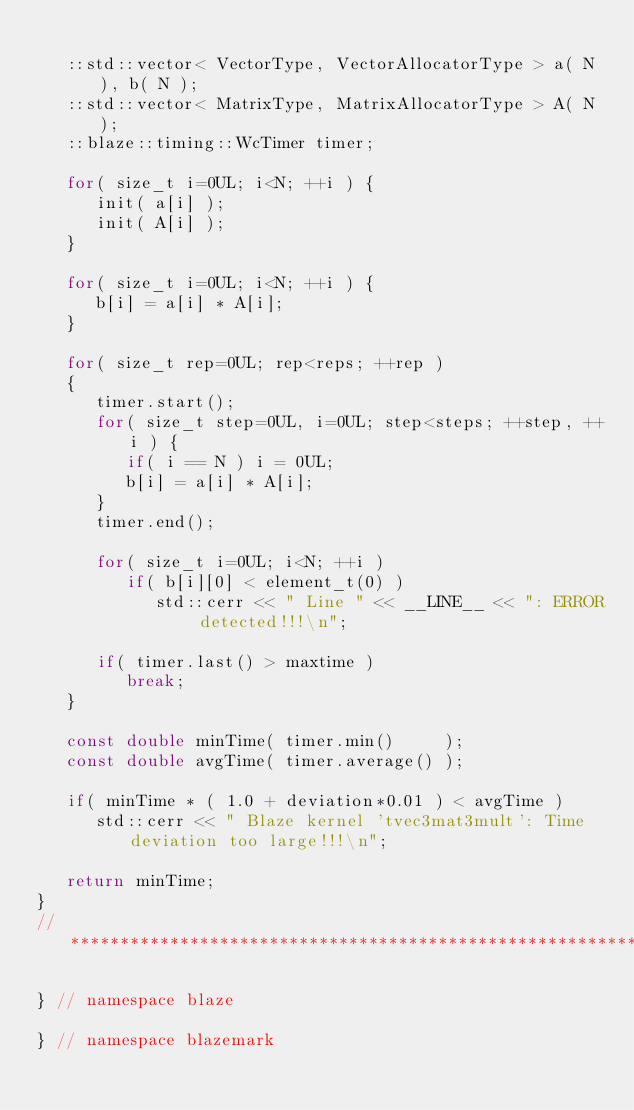Convert code to text. <code><loc_0><loc_0><loc_500><loc_500><_C++_>
   ::std::vector< VectorType, VectorAllocatorType > a( N ), b( N );
   ::std::vector< MatrixType, MatrixAllocatorType > A( N );
   ::blaze::timing::WcTimer timer;

   for( size_t i=0UL; i<N; ++i ) {
      init( a[i] );
      init( A[i] );
   }

   for( size_t i=0UL; i<N; ++i ) {
      b[i] = a[i] * A[i];
   }

   for( size_t rep=0UL; rep<reps; ++rep )
   {
      timer.start();
      for( size_t step=0UL, i=0UL; step<steps; ++step, ++i ) {
         if( i == N ) i = 0UL;
         b[i] = a[i] * A[i];
      }
      timer.end();

      for( size_t i=0UL; i<N; ++i )
         if( b[i][0] < element_t(0) )
            std::cerr << " Line " << __LINE__ << ": ERROR detected!!!\n";

      if( timer.last() > maxtime )
         break;
   }

   const double minTime( timer.min()     );
   const double avgTime( timer.average() );

   if( minTime * ( 1.0 + deviation*0.01 ) < avgTime )
      std::cerr << " Blaze kernel 'tvec3mat3mult': Time deviation too large!!!\n";

   return minTime;
}
//*************************************************************************************************

} // namespace blaze

} // namespace blazemark
</code> 